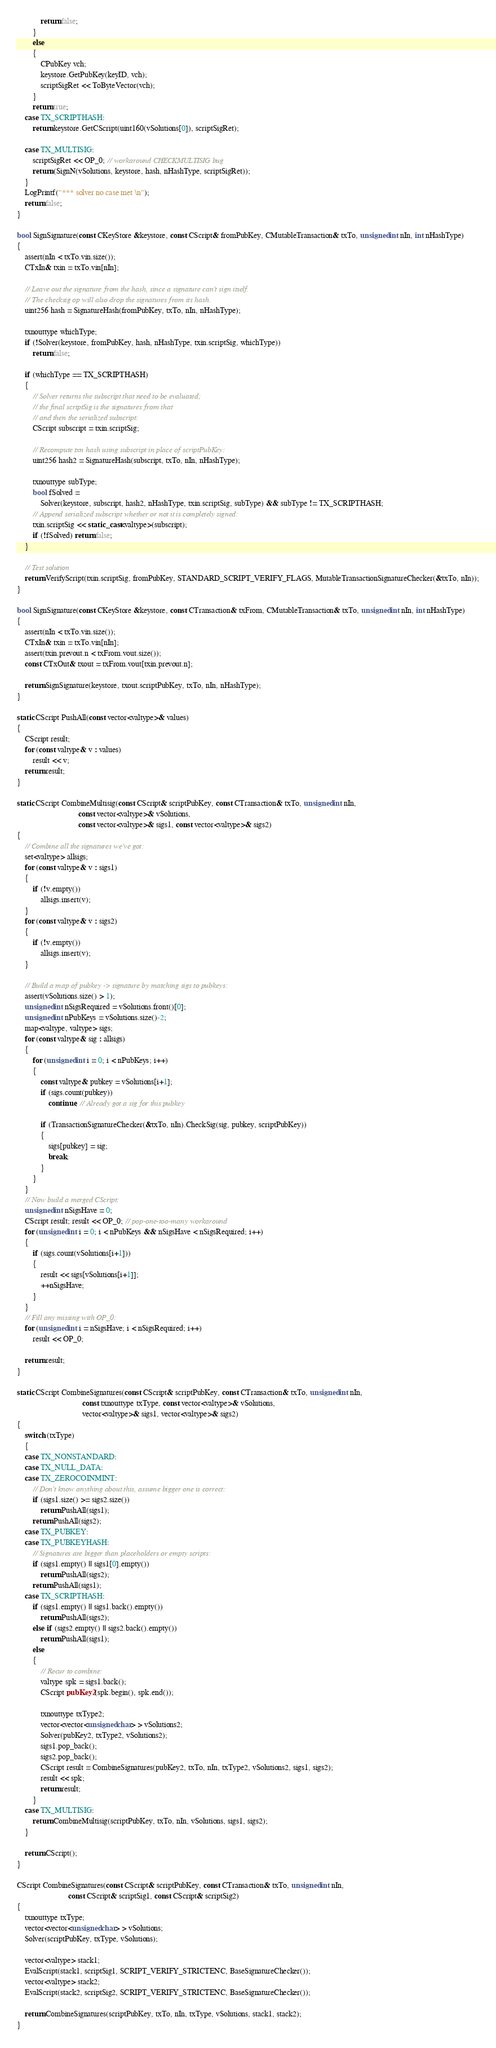Convert code to text. <code><loc_0><loc_0><loc_500><loc_500><_C++_>            return false;
        }
        else
        {
            CPubKey vch;
            keystore.GetPubKey(keyID, vch);
            scriptSigRet << ToByteVector(vch);
        }
        return true;
    case TX_SCRIPTHASH:
        return keystore.GetCScript(uint160(vSolutions[0]), scriptSigRet);

    case TX_MULTISIG:
        scriptSigRet << OP_0; // workaround CHECKMULTISIG bug
        return (SignN(vSolutions, keystore, hash, nHashType, scriptSigRet));
    }
    LogPrintf("*** solver no case met \n");
    return false;
}

bool SignSignature(const CKeyStore &keystore, const CScript& fromPubKey, CMutableTransaction& txTo, unsigned int nIn, int nHashType)
{
    assert(nIn < txTo.vin.size());
    CTxIn& txin = txTo.vin[nIn];

    // Leave out the signature from the hash, since a signature can't sign itself.
    // The checksig op will also drop the signatures from its hash.
    uint256 hash = SignatureHash(fromPubKey, txTo, nIn, nHashType);

    txnouttype whichType;
    if (!Solver(keystore, fromPubKey, hash, nHashType, txin.scriptSig, whichType))
        return false;

    if (whichType == TX_SCRIPTHASH)
    {
        // Solver returns the subscript that need to be evaluated;
        // the final scriptSig is the signatures from that
        // and then the serialized subscript:
        CScript subscript = txin.scriptSig;

        // Recompute txn hash using subscript in place of scriptPubKey:
        uint256 hash2 = SignatureHash(subscript, txTo, nIn, nHashType);

        txnouttype subType;
        bool fSolved =
            Solver(keystore, subscript, hash2, nHashType, txin.scriptSig, subType) && subType != TX_SCRIPTHASH;
        // Append serialized subscript whether or not it is completely signed:
        txin.scriptSig << static_cast<valtype>(subscript);
        if (!fSolved) return false;
    }

    // Test solution
    return VerifyScript(txin.scriptSig, fromPubKey, STANDARD_SCRIPT_VERIFY_FLAGS, MutableTransactionSignatureChecker(&txTo, nIn));
}

bool SignSignature(const CKeyStore &keystore, const CTransaction& txFrom, CMutableTransaction& txTo, unsigned int nIn, int nHashType)
{
    assert(nIn < txTo.vin.size());
    CTxIn& txin = txTo.vin[nIn];
    assert(txin.prevout.n < txFrom.vout.size());
    const CTxOut& txout = txFrom.vout[txin.prevout.n];

    return SignSignature(keystore, txout.scriptPubKey, txTo, nIn, nHashType);
}

static CScript PushAll(const vector<valtype>& values)
{
    CScript result;
    for (const valtype& v : values)
        result << v;
    return result;
}

static CScript CombineMultisig(const CScript& scriptPubKey, const CTransaction& txTo, unsigned int nIn,
                               const vector<valtype>& vSolutions,
                               const vector<valtype>& sigs1, const vector<valtype>& sigs2)
{
    // Combine all the signatures we've got:
    set<valtype> allsigs;
    for (const valtype& v : sigs1)
    {
        if (!v.empty())
            allsigs.insert(v);
    }
    for (const valtype& v : sigs2)
    {
        if (!v.empty())
            allsigs.insert(v);
    }

    // Build a map of pubkey -> signature by matching sigs to pubkeys:
    assert(vSolutions.size() > 1);
    unsigned int nSigsRequired = vSolutions.front()[0];
    unsigned int nPubKeys = vSolutions.size()-2;
    map<valtype, valtype> sigs;
    for (const valtype& sig : allsigs)
    {
        for (unsigned int i = 0; i < nPubKeys; i++)
        {
            const valtype& pubkey = vSolutions[i+1];
            if (sigs.count(pubkey))
                continue; // Already got a sig for this pubkey

            if (TransactionSignatureChecker(&txTo, nIn).CheckSig(sig, pubkey, scriptPubKey))
            {
                sigs[pubkey] = sig;
                break;
            }
        }
    }
    // Now build a merged CScript:
    unsigned int nSigsHave = 0;
    CScript result; result << OP_0; // pop-one-too-many workaround
    for (unsigned int i = 0; i < nPubKeys && nSigsHave < nSigsRequired; i++)
    {
        if (sigs.count(vSolutions[i+1]))
        {
            result << sigs[vSolutions[i+1]];
            ++nSigsHave;
        }
    }
    // Fill any missing with OP_0:
    for (unsigned int i = nSigsHave; i < nSigsRequired; i++)
        result << OP_0;

    return result;
}

static CScript CombineSignatures(const CScript& scriptPubKey, const CTransaction& txTo, unsigned int nIn,
                                 const txnouttype txType, const vector<valtype>& vSolutions,
                                 vector<valtype>& sigs1, vector<valtype>& sigs2)
{
    switch (txType)
    {
    case TX_NONSTANDARD:
    case TX_NULL_DATA:
    case TX_ZEROCOINMINT:
        // Don't know anything about this, assume bigger one is correct:
        if (sigs1.size() >= sigs2.size())
            return PushAll(sigs1);
        return PushAll(sigs2);
    case TX_PUBKEY:
    case TX_PUBKEYHASH:
        // Signatures are bigger than placeholders or empty scripts:
        if (sigs1.empty() || sigs1[0].empty())
            return PushAll(sigs2);
        return PushAll(sigs1);
    case TX_SCRIPTHASH:
        if (sigs1.empty() || sigs1.back().empty())
            return PushAll(sigs2);
        else if (sigs2.empty() || sigs2.back().empty())
            return PushAll(sigs1);
        else
        {
            // Recur to combine:
            valtype spk = sigs1.back();
            CScript pubKey2(spk.begin(), spk.end());

            txnouttype txType2;
            vector<vector<unsigned char> > vSolutions2;
            Solver(pubKey2, txType2, vSolutions2);
            sigs1.pop_back();
            sigs2.pop_back();
            CScript result = CombineSignatures(pubKey2, txTo, nIn, txType2, vSolutions2, sigs1, sigs2);
            result << spk;
            return result;
        }
    case TX_MULTISIG:
        return CombineMultisig(scriptPubKey, txTo, nIn, vSolutions, sigs1, sigs2);
    }

    return CScript();
}

CScript CombineSignatures(const CScript& scriptPubKey, const CTransaction& txTo, unsigned int nIn,
                          const CScript& scriptSig1, const CScript& scriptSig2)
{
    txnouttype txType;
    vector<vector<unsigned char> > vSolutions;
    Solver(scriptPubKey, txType, vSolutions);

    vector<valtype> stack1;
    EvalScript(stack1, scriptSig1, SCRIPT_VERIFY_STRICTENC, BaseSignatureChecker());
    vector<valtype> stack2;
    EvalScript(stack2, scriptSig2, SCRIPT_VERIFY_STRICTENC, BaseSignatureChecker());

    return CombineSignatures(scriptPubKey, txTo, nIn, txType, vSolutions, stack1, stack2);
}
</code> 